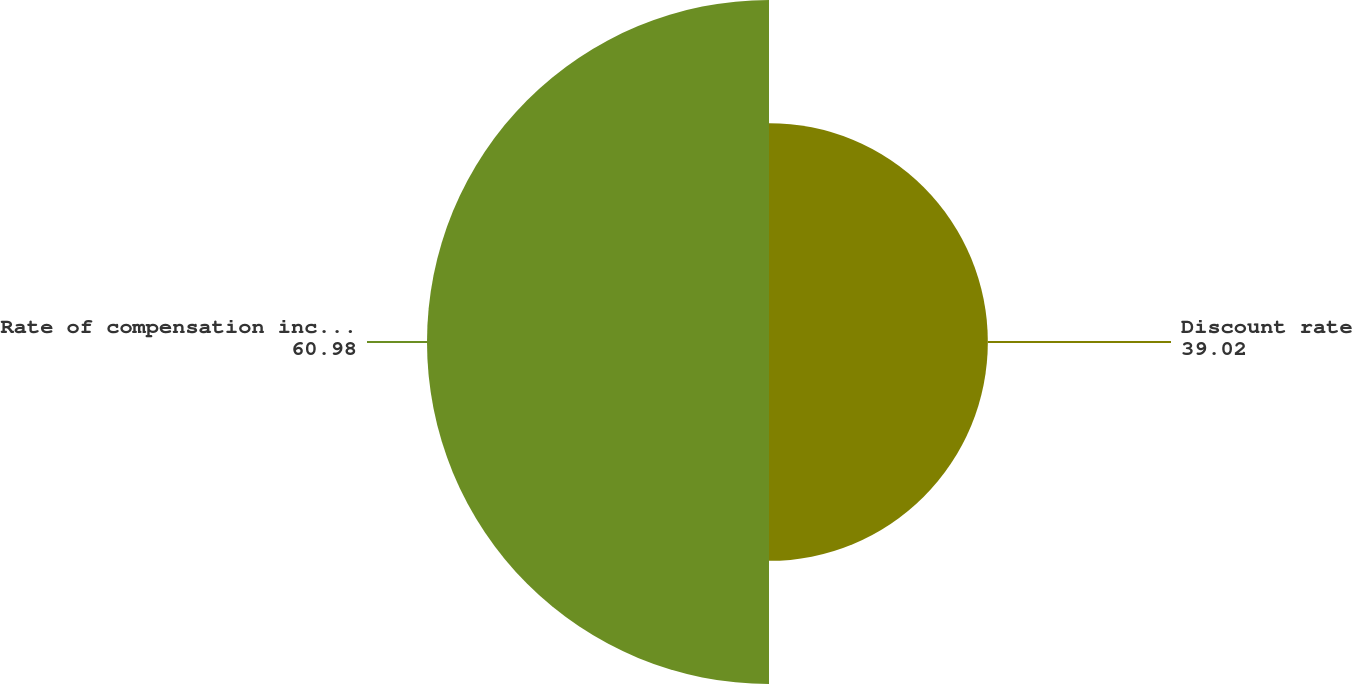<chart> <loc_0><loc_0><loc_500><loc_500><pie_chart><fcel>Discount rate<fcel>Rate of compensation increase<nl><fcel>39.02%<fcel>60.98%<nl></chart> 